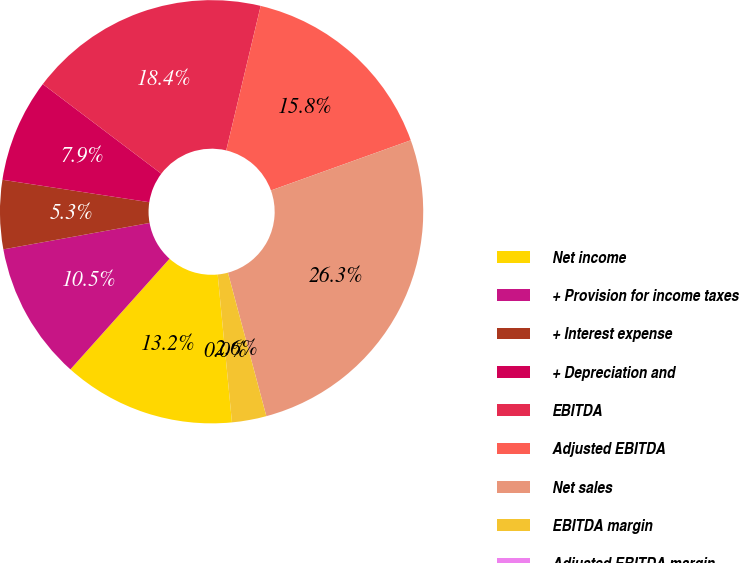<chart> <loc_0><loc_0><loc_500><loc_500><pie_chart><fcel>Net income<fcel>+ Provision for income taxes<fcel>+ Interest expense<fcel>+ Depreciation and<fcel>EBITDA<fcel>Adjusted EBITDA<fcel>Net sales<fcel>EBITDA margin<fcel>Adjusted EBITDA margin<nl><fcel>13.16%<fcel>10.53%<fcel>5.26%<fcel>7.89%<fcel>18.42%<fcel>15.79%<fcel>26.32%<fcel>2.63%<fcel>0.0%<nl></chart> 